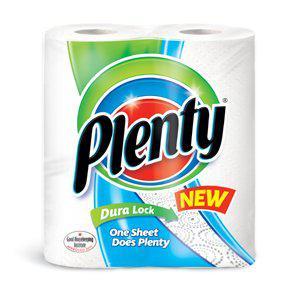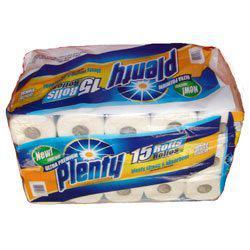The first image is the image on the left, the second image is the image on the right. For the images displayed, is the sentence "The paper towel package on the left features an image of three colored concentric rings, and the package on the right features a sunburst image." factually correct? Answer yes or no. Yes. The first image is the image on the left, the second image is the image on the right. Given the left and right images, does the statement "Two packages of the same brand of multiple rolls of paper towels are shown, the smaller package with least two rolls, and the larger package at least twice as large as the smaller one." hold true? Answer yes or no. Yes. 